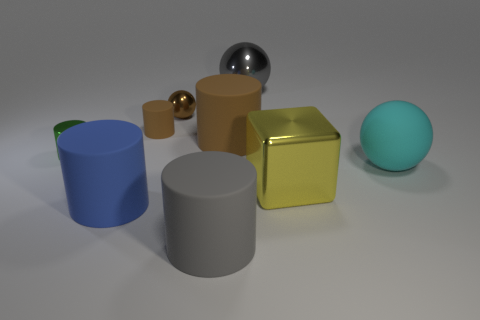What shape is the small thing that is the same color as the small rubber cylinder?
Keep it short and to the point. Sphere. There is a big rubber cylinder in front of the large blue cylinder; is its color the same as the shiny thing that is behind the small brown metal sphere?
Ensure brevity in your answer.  Yes. Is the size of the yellow metal object to the right of the large gray matte cylinder the same as the gray object that is in front of the cyan ball?
Your answer should be compact. Yes. How many other objects are there of the same size as the blue object?
Offer a very short reply. 5. How many tiny balls are in front of the thing that is behind the tiny brown sphere?
Give a very brief answer. 1. Are there fewer yellow things left of the rubber sphere than big blue cylinders?
Your response must be concise. No. The tiny brown rubber thing that is left of the matte cylinder on the right side of the large gray object that is in front of the yellow shiny object is what shape?
Your answer should be very brief. Cylinder. Does the small green object have the same shape as the small rubber object?
Ensure brevity in your answer.  Yes. How many other things are there of the same shape as the tiny rubber object?
Offer a very short reply. 4. What color is the matte sphere that is the same size as the yellow shiny thing?
Your answer should be compact. Cyan. 